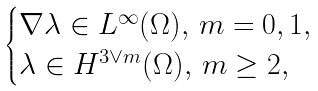Convert formula to latex. <formula><loc_0><loc_0><loc_500><loc_500>\begin{cases} \nabla \lambda \in L ^ { \infty } ( \Omega ) , \, m = 0 , 1 , \\ \lambda \in H ^ { 3 \vee m } ( \Omega ) , \, m \geq 2 , \\ \end{cases}</formula> 